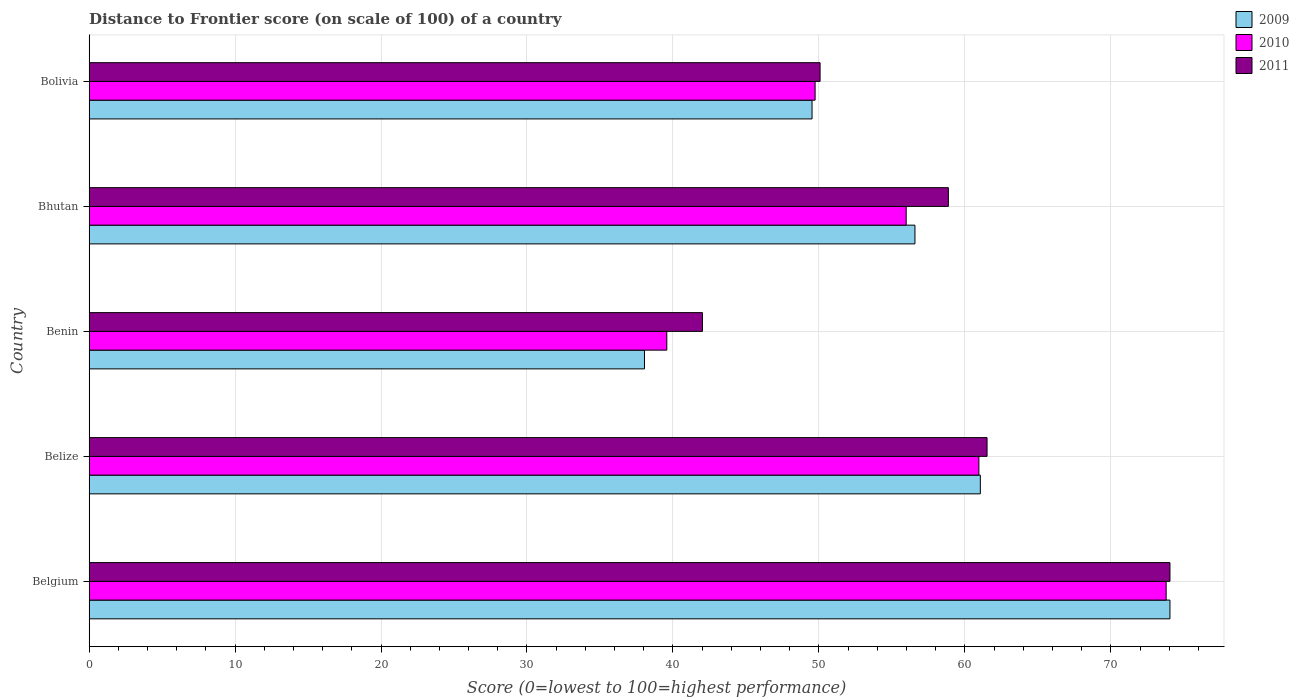How many different coloured bars are there?
Your answer should be very brief. 3. Are the number of bars per tick equal to the number of legend labels?
Offer a very short reply. Yes. Are the number of bars on each tick of the Y-axis equal?
Provide a short and direct response. Yes. How many bars are there on the 1st tick from the top?
Your answer should be very brief. 3. How many bars are there on the 2nd tick from the bottom?
Your response must be concise. 3. What is the label of the 5th group of bars from the top?
Make the answer very short. Belgium. What is the distance to frontier score of in 2011 in Benin?
Offer a very short reply. 42.02. Across all countries, what is the maximum distance to frontier score of in 2009?
Provide a succinct answer. 74.05. Across all countries, what is the minimum distance to frontier score of in 2009?
Offer a very short reply. 38.05. In which country was the distance to frontier score of in 2010 minimum?
Give a very brief answer. Benin. What is the total distance to frontier score of in 2009 in the graph?
Offer a very short reply. 279.27. What is the difference between the distance to frontier score of in 2010 in Belize and that in Bolivia?
Offer a terse response. 11.22. What is the difference between the distance to frontier score of in 2009 in Bhutan and the distance to frontier score of in 2010 in Belgium?
Offer a very short reply. -17.21. What is the average distance to frontier score of in 2009 per country?
Offer a terse response. 55.85. What is the difference between the distance to frontier score of in 2011 and distance to frontier score of in 2010 in Belize?
Ensure brevity in your answer.  0.56. What is the ratio of the distance to frontier score of in 2010 in Belgium to that in Benin?
Ensure brevity in your answer.  1.86. Is the difference between the distance to frontier score of in 2011 in Belgium and Bhutan greater than the difference between the distance to frontier score of in 2010 in Belgium and Bhutan?
Your response must be concise. No. What is the difference between the highest and the second highest distance to frontier score of in 2011?
Your response must be concise. 12.53. What is the difference between the highest and the lowest distance to frontier score of in 2010?
Ensure brevity in your answer.  34.21. In how many countries, is the distance to frontier score of in 2010 greater than the average distance to frontier score of in 2010 taken over all countries?
Make the answer very short. 2. What does the 1st bar from the bottom in Belize represents?
Ensure brevity in your answer.  2009. How many bars are there?
Provide a succinct answer. 15. Are the values on the major ticks of X-axis written in scientific E-notation?
Your answer should be compact. No. How are the legend labels stacked?
Offer a very short reply. Vertical. What is the title of the graph?
Offer a terse response. Distance to Frontier score (on scale of 100) of a country. What is the label or title of the X-axis?
Make the answer very short. Score (0=lowest to 100=highest performance). What is the Score (0=lowest to 100=highest performance) in 2009 in Belgium?
Ensure brevity in your answer.  74.05. What is the Score (0=lowest to 100=highest performance) in 2010 in Belgium?
Ensure brevity in your answer.  73.79. What is the Score (0=lowest to 100=highest performance) of 2011 in Belgium?
Ensure brevity in your answer.  74.05. What is the Score (0=lowest to 100=highest performance) in 2009 in Belize?
Offer a terse response. 61.06. What is the Score (0=lowest to 100=highest performance) in 2010 in Belize?
Ensure brevity in your answer.  60.96. What is the Score (0=lowest to 100=highest performance) in 2011 in Belize?
Ensure brevity in your answer.  61.52. What is the Score (0=lowest to 100=highest performance) of 2009 in Benin?
Provide a short and direct response. 38.05. What is the Score (0=lowest to 100=highest performance) of 2010 in Benin?
Your response must be concise. 39.58. What is the Score (0=lowest to 100=highest performance) of 2011 in Benin?
Your answer should be very brief. 42.02. What is the Score (0=lowest to 100=highest performance) of 2009 in Bhutan?
Provide a short and direct response. 56.58. What is the Score (0=lowest to 100=highest performance) of 2010 in Bhutan?
Give a very brief answer. 55.98. What is the Score (0=lowest to 100=highest performance) of 2011 in Bhutan?
Provide a succinct answer. 58.87. What is the Score (0=lowest to 100=highest performance) of 2009 in Bolivia?
Keep it short and to the point. 49.53. What is the Score (0=lowest to 100=highest performance) of 2010 in Bolivia?
Your answer should be compact. 49.74. What is the Score (0=lowest to 100=highest performance) of 2011 in Bolivia?
Ensure brevity in your answer.  50.08. Across all countries, what is the maximum Score (0=lowest to 100=highest performance) in 2009?
Offer a terse response. 74.05. Across all countries, what is the maximum Score (0=lowest to 100=highest performance) in 2010?
Your response must be concise. 73.79. Across all countries, what is the maximum Score (0=lowest to 100=highest performance) of 2011?
Your answer should be very brief. 74.05. Across all countries, what is the minimum Score (0=lowest to 100=highest performance) in 2009?
Provide a short and direct response. 38.05. Across all countries, what is the minimum Score (0=lowest to 100=highest performance) in 2010?
Your answer should be compact. 39.58. Across all countries, what is the minimum Score (0=lowest to 100=highest performance) in 2011?
Ensure brevity in your answer.  42.02. What is the total Score (0=lowest to 100=highest performance) of 2009 in the graph?
Ensure brevity in your answer.  279.27. What is the total Score (0=lowest to 100=highest performance) in 2010 in the graph?
Offer a very short reply. 280.05. What is the total Score (0=lowest to 100=highest performance) in 2011 in the graph?
Your response must be concise. 286.54. What is the difference between the Score (0=lowest to 100=highest performance) of 2009 in Belgium and that in Belize?
Make the answer very short. 12.99. What is the difference between the Score (0=lowest to 100=highest performance) in 2010 in Belgium and that in Belize?
Ensure brevity in your answer.  12.83. What is the difference between the Score (0=lowest to 100=highest performance) of 2011 in Belgium and that in Belize?
Ensure brevity in your answer.  12.53. What is the difference between the Score (0=lowest to 100=highest performance) of 2010 in Belgium and that in Benin?
Keep it short and to the point. 34.21. What is the difference between the Score (0=lowest to 100=highest performance) of 2011 in Belgium and that in Benin?
Offer a terse response. 32.03. What is the difference between the Score (0=lowest to 100=highest performance) of 2009 in Belgium and that in Bhutan?
Your answer should be very brief. 17.47. What is the difference between the Score (0=lowest to 100=highest performance) in 2010 in Belgium and that in Bhutan?
Make the answer very short. 17.81. What is the difference between the Score (0=lowest to 100=highest performance) in 2011 in Belgium and that in Bhutan?
Provide a succinct answer. 15.18. What is the difference between the Score (0=lowest to 100=highest performance) of 2009 in Belgium and that in Bolivia?
Ensure brevity in your answer.  24.52. What is the difference between the Score (0=lowest to 100=highest performance) in 2010 in Belgium and that in Bolivia?
Give a very brief answer. 24.05. What is the difference between the Score (0=lowest to 100=highest performance) in 2011 in Belgium and that in Bolivia?
Your answer should be compact. 23.97. What is the difference between the Score (0=lowest to 100=highest performance) of 2009 in Belize and that in Benin?
Your response must be concise. 23.01. What is the difference between the Score (0=lowest to 100=highest performance) of 2010 in Belize and that in Benin?
Provide a succinct answer. 21.38. What is the difference between the Score (0=lowest to 100=highest performance) in 2011 in Belize and that in Benin?
Your response must be concise. 19.5. What is the difference between the Score (0=lowest to 100=highest performance) in 2009 in Belize and that in Bhutan?
Provide a short and direct response. 4.48. What is the difference between the Score (0=lowest to 100=highest performance) of 2010 in Belize and that in Bhutan?
Provide a succinct answer. 4.98. What is the difference between the Score (0=lowest to 100=highest performance) in 2011 in Belize and that in Bhutan?
Your answer should be compact. 2.65. What is the difference between the Score (0=lowest to 100=highest performance) of 2009 in Belize and that in Bolivia?
Give a very brief answer. 11.53. What is the difference between the Score (0=lowest to 100=highest performance) in 2010 in Belize and that in Bolivia?
Make the answer very short. 11.22. What is the difference between the Score (0=lowest to 100=highest performance) of 2011 in Belize and that in Bolivia?
Ensure brevity in your answer.  11.44. What is the difference between the Score (0=lowest to 100=highest performance) in 2009 in Benin and that in Bhutan?
Offer a terse response. -18.53. What is the difference between the Score (0=lowest to 100=highest performance) in 2010 in Benin and that in Bhutan?
Keep it short and to the point. -16.4. What is the difference between the Score (0=lowest to 100=highest performance) of 2011 in Benin and that in Bhutan?
Offer a terse response. -16.85. What is the difference between the Score (0=lowest to 100=highest performance) of 2009 in Benin and that in Bolivia?
Offer a very short reply. -11.48. What is the difference between the Score (0=lowest to 100=highest performance) of 2010 in Benin and that in Bolivia?
Make the answer very short. -10.16. What is the difference between the Score (0=lowest to 100=highest performance) of 2011 in Benin and that in Bolivia?
Provide a succinct answer. -8.06. What is the difference between the Score (0=lowest to 100=highest performance) in 2009 in Bhutan and that in Bolivia?
Your response must be concise. 7.05. What is the difference between the Score (0=lowest to 100=highest performance) in 2010 in Bhutan and that in Bolivia?
Your answer should be compact. 6.24. What is the difference between the Score (0=lowest to 100=highest performance) in 2011 in Bhutan and that in Bolivia?
Ensure brevity in your answer.  8.79. What is the difference between the Score (0=lowest to 100=highest performance) of 2009 in Belgium and the Score (0=lowest to 100=highest performance) of 2010 in Belize?
Offer a terse response. 13.09. What is the difference between the Score (0=lowest to 100=highest performance) of 2009 in Belgium and the Score (0=lowest to 100=highest performance) of 2011 in Belize?
Keep it short and to the point. 12.53. What is the difference between the Score (0=lowest to 100=highest performance) of 2010 in Belgium and the Score (0=lowest to 100=highest performance) of 2011 in Belize?
Your answer should be very brief. 12.27. What is the difference between the Score (0=lowest to 100=highest performance) of 2009 in Belgium and the Score (0=lowest to 100=highest performance) of 2010 in Benin?
Your answer should be very brief. 34.47. What is the difference between the Score (0=lowest to 100=highest performance) of 2009 in Belgium and the Score (0=lowest to 100=highest performance) of 2011 in Benin?
Offer a very short reply. 32.03. What is the difference between the Score (0=lowest to 100=highest performance) of 2010 in Belgium and the Score (0=lowest to 100=highest performance) of 2011 in Benin?
Make the answer very short. 31.77. What is the difference between the Score (0=lowest to 100=highest performance) in 2009 in Belgium and the Score (0=lowest to 100=highest performance) in 2010 in Bhutan?
Provide a succinct answer. 18.07. What is the difference between the Score (0=lowest to 100=highest performance) of 2009 in Belgium and the Score (0=lowest to 100=highest performance) of 2011 in Bhutan?
Keep it short and to the point. 15.18. What is the difference between the Score (0=lowest to 100=highest performance) in 2010 in Belgium and the Score (0=lowest to 100=highest performance) in 2011 in Bhutan?
Provide a short and direct response. 14.92. What is the difference between the Score (0=lowest to 100=highest performance) in 2009 in Belgium and the Score (0=lowest to 100=highest performance) in 2010 in Bolivia?
Your answer should be compact. 24.31. What is the difference between the Score (0=lowest to 100=highest performance) of 2009 in Belgium and the Score (0=lowest to 100=highest performance) of 2011 in Bolivia?
Provide a succinct answer. 23.97. What is the difference between the Score (0=lowest to 100=highest performance) in 2010 in Belgium and the Score (0=lowest to 100=highest performance) in 2011 in Bolivia?
Your answer should be very brief. 23.71. What is the difference between the Score (0=lowest to 100=highest performance) in 2009 in Belize and the Score (0=lowest to 100=highest performance) in 2010 in Benin?
Make the answer very short. 21.48. What is the difference between the Score (0=lowest to 100=highest performance) in 2009 in Belize and the Score (0=lowest to 100=highest performance) in 2011 in Benin?
Your answer should be very brief. 19.04. What is the difference between the Score (0=lowest to 100=highest performance) in 2010 in Belize and the Score (0=lowest to 100=highest performance) in 2011 in Benin?
Provide a short and direct response. 18.94. What is the difference between the Score (0=lowest to 100=highest performance) in 2009 in Belize and the Score (0=lowest to 100=highest performance) in 2010 in Bhutan?
Keep it short and to the point. 5.08. What is the difference between the Score (0=lowest to 100=highest performance) of 2009 in Belize and the Score (0=lowest to 100=highest performance) of 2011 in Bhutan?
Keep it short and to the point. 2.19. What is the difference between the Score (0=lowest to 100=highest performance) in 2010 in Belize and the Score (0=lowest to 100=highest performance) in 2011 in Bhutan?
Make the answer very short. 2.09. What is the difference between the Score (0=lowest to 100=highest performance) in 2009 in Belize and the Score (0=lowest to 100=highest performance) in 2010 in Bolivia?
Give a very brief answer. 11.32. What is the difference between the Score (0=lowest to 100=highest performance) of 2009 in Belize and the Score (0=lowest to 100=highest performance) of 2011 in Bolivia?
Make the answer very short. 10.98. What is the difference between the Score (0=lowest to 100=highest performance) of 2010 in Belize and the Score (0=lowest to 100=highest performance) of 2011 in Bolivia?
Your response must be concise. 10.88. What is the difference between the Score (0=lowest to 100=highest performance) in 2009 in Benin and the Score (0=lowest to 100=highest performance) in 2010 in Bhutan?
Your answer should be compact. -17.93. What is the difference between the Score (0=lowest to 100=highest performance) of 2009 in Benin and the Score (0=lowest to 100=highest performance) of 2011 in Bhutan?
Make the answer very short. -20.82. What is the difference between the Score (0=lowest to 100=highest performance) in 2010 in Benin and the Score (0=lowest to 100=highest performance) in 2011 in Bhutan?
Offer a very short reply. -19.29. What is the difference between the Score (0=lowest to 100=highest performance) in 2009 in Benin and the Score (0=lowest to 100=highest performance) in 2010 in Bolivia?
Give a very brief answer. -11.69. What is the difference between the Score (0=lowest to 100=highest performance) of 2009 in Benin and the Score (0=lowest to 100=highest performance) of 2011 in Bolivia?
Your response must be concise. -12.03. What is the difference between the Score (0=lowest to 100=highest performance) of 2009 in Bhutan and the Score (0=lowest to 100=highest performance) of 2010 in Bolivia?
Make the answer very short. 6.84. What is the difference between the Score (0=lowest to 100=highest performance) in 2010 in Bhutan and the Score (0=lowest to 100=highest performance) in 2011 in Bolivia?
Offer a terse response. 5.9. What is the average Score (0=lowest to 100=highest performance) of 2009 per country?
Your answer should be very brief. 55.85. What is the average Score (0=lowest to 100=highest performance) of 2010 per country?
Your answer should be compact. 56.01. What is the average Score (0=lowest to 100=highest performance) in 2011 per country?
Offer a terse response. 57.31. What is the difference between the Score (0=lowest to 100=highest performance) in 2009 and Score (0=lowest to 100=highest performance) in 2010 in Belgium?
Keep it short and to the point. 0.26. What is the difference between the Score (0=lowest to 100=highest performance) of 2009 and Score (0=lowest to 100=highest performance) of 2011 in Belgium?
Provide a succinct answer. 0. What is the difference between the Score (0=lowest to 100=highest performance) of 2010 and Score (0=lowest to 100=highest performance) of 2011 in Belgium?
Ensure brevity in your answer.  -0.26. What is the difference between the Score (0=lowest to 100=highest performance) of 2009 and Score (0=lowest to 100=highest performance) of 2010 in Belize?
Ensure brevity in your answer.  0.1. What is the difference between the Score (0=lowest to 100=highest performance) in 2009 and Score (0=lowest to 100=highest performance) in 2011 in Belize?
Give a very brief answer. -0.46. What is the difference between the Score (0=lowest to 100=highest performance) of 2010 and Score (0=lowest to 100=highest performance) of 2011 in Belize?
Give a very brief answer. -0.56. What is the difference between the Score (0=lowest to 100=highest performance) of 2009 and Score (0=lowest to 100=highest performance) of 2010 in Benin?
Provide a short and direct response. -1.53. What is the difference between the Score (0=lowest to 100=highest performance) in 2009 and Score (0=lowest to 100=highest performance) in 2011 in Benin?
Your answer should be very brief. -3.97. What is the difference between the Score (0=lowest to 100=highest performance) in 2010 and Score (0=lowest to 100=highest performance) in 2011 in Benin?
Keep it short and to the point. -2.44. What is the difference between the Score (0=lowest to 100=highest performance) of 2009 and Score (0=lowest to 100=highest performance) of 2010 in Bhutan?
Ensure brevity in your answer.  0.6. What is the difference between the Score (0=lowest to 100=highest performance) of 2009 and Score (0=lowest to 100=highest performance) of 2011 in Bhutan?
Ensure brevity in your answer.  -2.29. What is the difference between the Score (0=lowest to 100=highest performance) of 2010 and Score (0=lowest to 100=highest performance) of 2011 in Bhutan?
Offer a very short reply. -2.89. What is the difference between the Score (0=lowest to 100=highest performance) in 2009 and Score (0=lowest to 100=highest performance) in 2010 in Bolivia?
Your response must be concise. -0.21. What is the difference between the Score (0=lowest to 100=highest performance) of 2009 and Score (0=lowest to 100=highest performance) of 2011 in Bolivia?
Your answer should be very brief. -0.55. What is the difference between the Score (0=lowest to 100=highest performance) in 2010 and Score (0=lowest to 100=highest performance) in 2011 in Bolivia?
Your answer should be very brief. -0.34. What is the ratio of the Score (0=lowest to 100=highest performance) of 2009 in Belgium to that in Belize?
Your response must be concise. 1.21. What is the ratio of the Score (0=lowest to 100=highest performance) in 2010 in Belgium to that in Belize?
Your answer should be compact. 1.21. What is the ratio of the Score (0=lowest to 100=highest performance) in 2011 in Belgium to that in Belize?
Your response must be concise. 1.2. What is the ratio of the Score (0=lowest to 100=highest performance) in 2009 in Belgium to that in Benin?
Your answer should be compact. 1.95. What is the ratio of the Score (0=lowest to 100=highest performance) in 2010 in Belgium to that in Benin?
Your answer should be very brief. 1.86. What is the ratio of the Score (0=lowest to 100=highest performance) of 2011 in Belgium to that in Benin?
Make the answer very short. 1.76. What is the ratio of the Score (0=lowest to 100=highest performance) in 2009 in Belgium to that in Bhutan?
Keep it short and to the point. 1.31. What is the ratio of the Score (0=lowest to 100=highest performance) of 2010 in Belgium to that in Bhutan?
Your answer should be very brief. 1.32. What is the ratio of the Score (0=lowest to 100=highest performance) of 2011 in Belgium to that in Bhutan?
Keep it short and to the point. 1.26. What is the ratio of the Score (0=lowest to 100=highest performance) of 2009 in Belgium to that in Bolivia?
Your response must be concise. 1.5. What is the ratio of the Score (0=lowest to 100=highest performance) in 2010 in Belgium to that in Bolivia?
Make the answer very short. 1.48. What is the ratio of the Score (0=lowest to 100=highest performance) in 2011 in Belgium to that in Bolivia?
Provide a succinct answer. 1.48. What is the ratio of the Score (0=lowest to 100=highest performance) in 2009 in Belize to that in Benin?
Your answer should be very brief. 1.6. What is the ratio of the Score (0=lowest to 100=highest performance) in 2010 in Belize to that in Benin?
Make the answer very short. 1.54. What is the ratio of the Score (0=lowest to 100=highest performance) in 2011 in Belize to that in Benin?
Make the answer very short. 1.46. What is the ratio of the Score (0=lowest to 100=highest performance) in 2009 in Belize to that in Bhutan?
Your answer should be compact. 1.08. What is the ratio of the Score (0=lowest to 100=highest performance) of 2010 in Belize to that in Bhutan?
Give a very brief answer. 1.09. What is the ratio of the Score (0=lowest to 100=highest performance) in 2011 in Belize to that in Bhutan?
Make the answer very short. 1.04. What is the ratio of the Score (0=lowest to 100=highest performance) in 2009 in Belize to that in Bolivia?
Keep it short and to the point. 1.23. What is the ratio of the Score (0=lowest to 100=highest performance) in 2010 in Belize to that in Bolivia?
Provide a succinct answer. 1.23. What is the ratio of the Score (0=lowest to 100=highest performance) in 2011 in Belize to that in Bolivia?
Your response must be concise. 1.23. What is the ratio of the Score (0=lowest to 100=highest performance) of 2009 in Benin to that in Bhutan?
Offer a very short reply. 0.67. What is the ratio of the Score (0=lowest to 100=highest performance) of 2010 in Benin to that in Bhutan?
Offer a very short reply. 0.71. What is the ratio of the Score (0=lowest to 100=highest performance) in 2011 in Benin to that in Bhutan?
Your response must be concise. 0.71. What is the ratio of the Score (0=lowest to 100=highest performance) in 2009 in Benin to that in Bolivia?
Your answer should be very brief. 0.77. What is the ratio of the Score (0=lowest to 100=highest performance) in 2010 in Benin to that in Bolivia?
Provide a succinct answer. 0.8. What is the ratio of the Score (0=lowest to 100=highest performance) in 2011 in Benin to that in Bolivia?
Make the answer very short. 0.84. What is the ratio of the Score (0=lowest to 100=highest performance) in 2009 in Bhutan to that in Bolivia?
Keep it short and to the point. 1.14. What is the ratio of the Score (0=lowest to 100=highest performance) in 2010 in Bhutan to that in Bolivia?
Make the answer very short. 1.13. What is the ratio of the Score (0=lowest to 100=highest performance) in 2011 in Bhutan to that in Bolivia?
Offer a very short reply. 1.18. What is the difference between the highest and the second highest Score (0=lowest to 100=highest performance) in 2009?
Ensure brevity in your answer.  12.99. What is the difference between the highest and the second highest Score (0=lowest to 100=highest performance) in 2010?
Offer a terse response. 12.83. What is the difference between the highest and the second highest Score (0=lowest to 100=highest performance) in 2011?
Give a very brief answer. 12.53. What is the difference between the highest and the lowest Score (0=lowest to 100=highest performance) in 2010?
Make the answer very short. 34.21. What is the difference between the highest and the lowest Score (0=lowest to 100=highest performance) of 2011?
Your response must be concise. 32.03. 